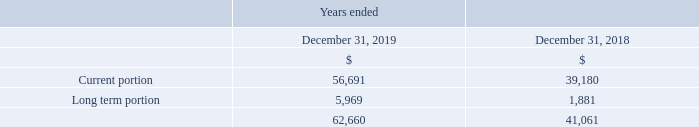Deferred Revenue
The opening balances of current and long-term deferred revenue were $30,694 and $1,352, respectively, as of January 1, 2018.
Expressed in US $000's except share and per share amounts
What is the current portion of deferred revenue in 2019?
Answer scale should be: thousand. 56,691. What was the January 1, 2018 opening balance of current deferred revenue? $30,694. What was the January 1, 2018 opening balance of long-term deferred revenue? $1,352. How much has current deferred revenue changed from January 1, 2018 to December 31, 2018?
Answer scale should be: thousand. 39,180-30,694
Answer: 8486. How much has long-term deferred revenue changed from January 1, 2018 to December 31, 2018?
Answer scale should be: thousand. 1,881-1,352
Answer: 529. Between 2018 and 2019, which year had a higher amount of total deferred revenue? 62,660>41,061
Answer: 2019. 